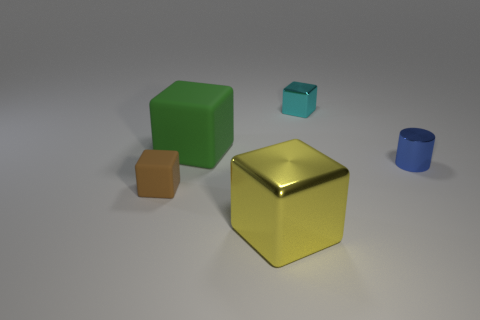Subtract all big yellow metallic blocks. How many blocks are left? 3 Subtract all brown blocks. How many blocks are left? 3 Add 5 big things. How many objects exist? 10 Subtract all cubes. How many objects are left? 1 Subtract all green blocks. Subtract all green spheres. How many blocks are left? 3 Subtract all tiny cyan metallic objects. Subtract all small blue things. How many objects are left? 3 Add 4 tiny matte objects. How many tiny matte objects are left? 5 Add 4 cyan shiny objects. How many cyan shiny objects exist? 5 Subtract 0 green cylinders. How many objects are left? 5 